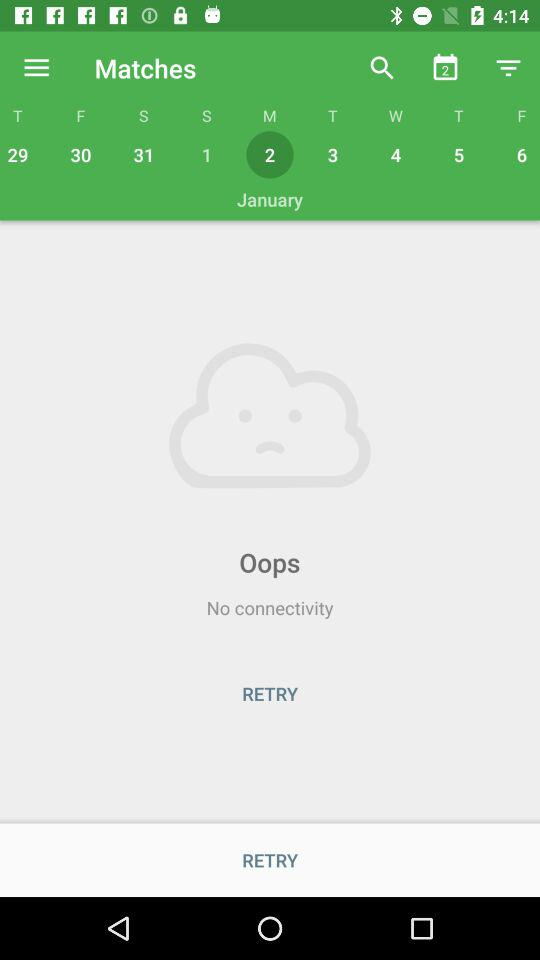Which is the selected date? The selected date is Monday, January 2. 